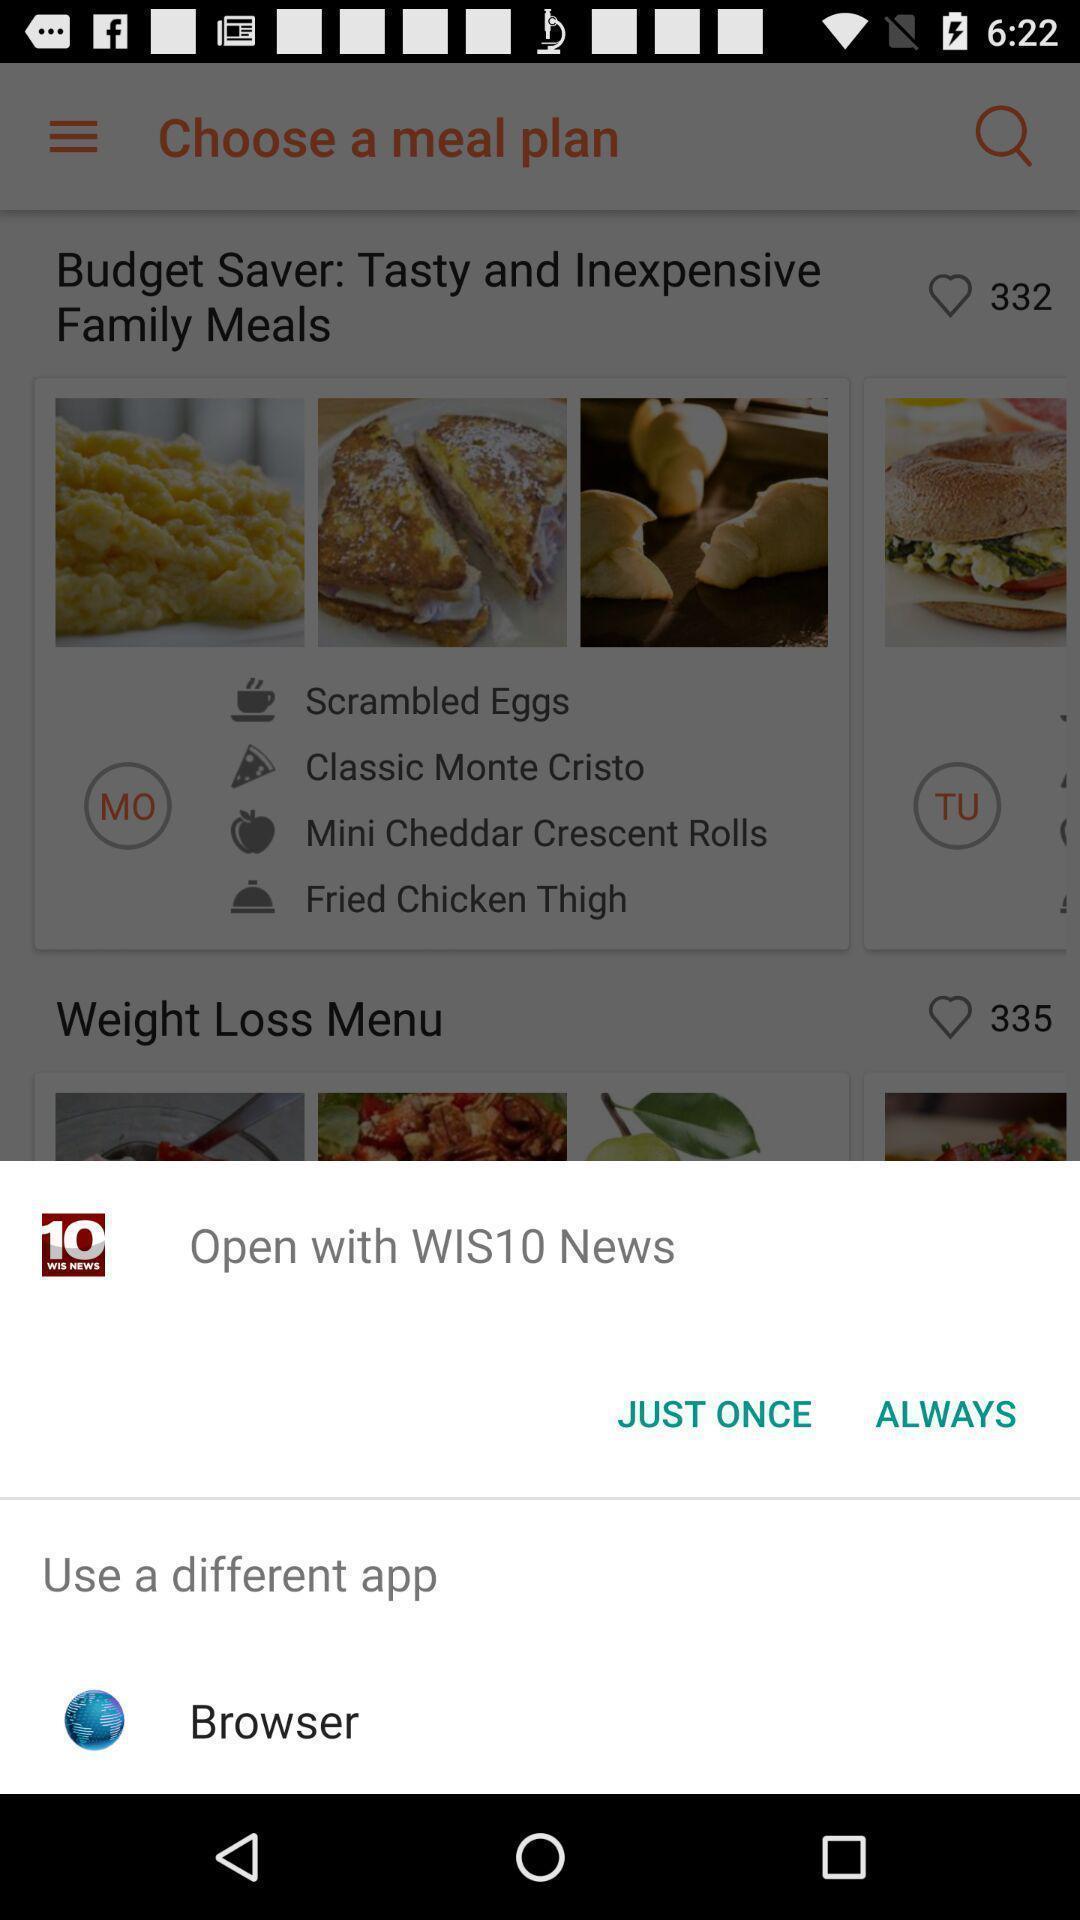Please provide a description for this image. Screen showing multiple options to open with. 